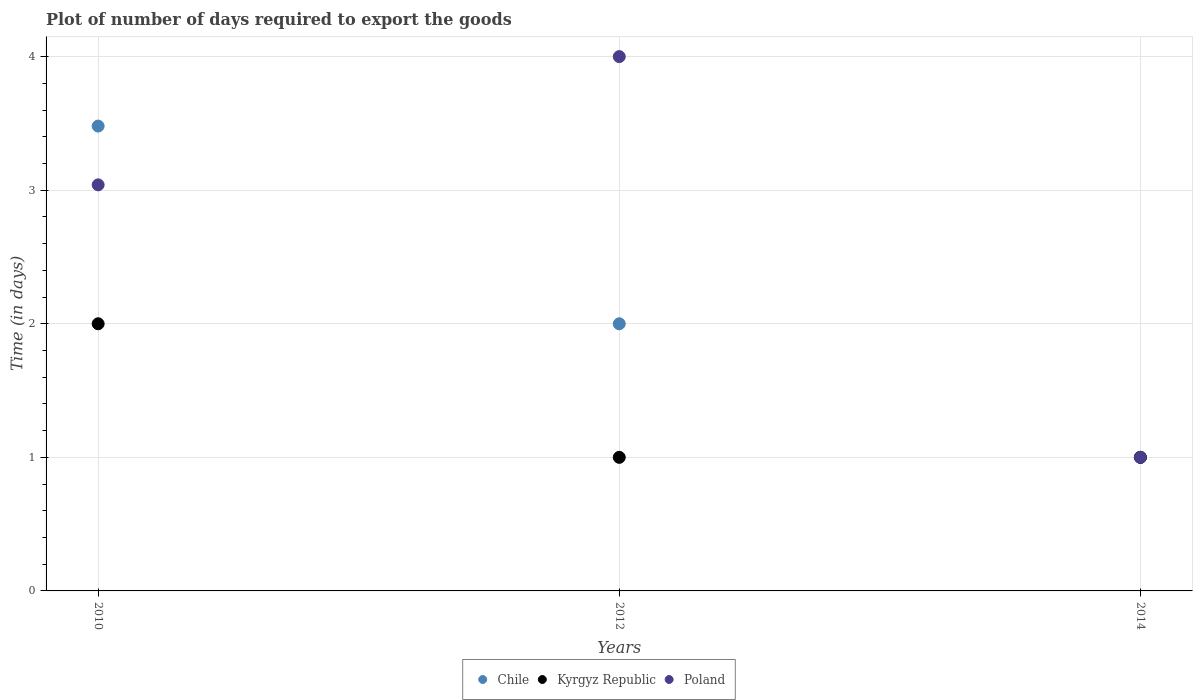How many different coloured dotlines are there?
Keep it short and to the point. 3. Across all years, what is the maximum time required to export goods in Chile?
Offer a very short reply. 3.48. In which year was the time required to export goods in Chile maximum?
Ensure brevity in your answer.  2010. What is the total time required to export goods in Poland in the graph?
Your response must be concise. 8.04. What is the difference between the time required to export goods in Chile in 2010 and that in 2012?
Offer a terse response. 1.48. What is the difference between the time required to export goods in Chile in 2014 and the time required to export goods in Kyrgyz Republic in 2012?
Your response must be concise. 0. What is the average time required to export goods in Chile per year?
Your answer should be compact. 2.16. In the year 2014, what is the difference between the time required to export goods in Poland and time required to export goods in Chile?
Make the answer very short. 0. In how many years, is the time required to export goods in Poland greater than 0.4 days?
Give a very brief answer. 3. What is the difference between the highest and the second highest time required to export goods in Kyrgyz Republic?
Your answer should be compact. 1. What is the difference between the highest and the lowest time required to export goods in Kyrgyz Republic?
Keep it short and to the point. 1. In how many years, is the time required to export goods in Poland greater than the average time required to export goods in Poland taken over all years?
Make the answer very short. 2. Is the time required to export goods in Kyrgyz Republic strictly greater than the time required to export goods in Chile over the years?
Make the answer very short. No. Is the time required to export goods in Poland strictly less than the time required to export goods in Chile over the years?
Your response must be concise. No. How many dotlines are there?
Your response must be concise. 3. Are the values on the major ticks of Y-axis written in scientific E-notation?
Make the answer very short. No. Does the graph contain grids?
Make the answer very short. Yes. Where does the legend appear in the graph?
Your response must be concise. Bottom center. How many legend labels are there?
Your answer should be very brief. 3. How are the legend labels stacked?
Make the answer very short. Horizontal. What is the title of the graph?
Your response must be concise. Plot of number of days required to export the goods. Does "Aruba" appear as one of the legend labels in the graph?
Offer a very short reply. No. What is the label or title of the X-axis?
Keep it short and to the point. Years. What is the label or title of the Y-axis?
Keep it short and to the point. Time (in days). What is the Time (in days) in Chile in 2010?
Give a very brief answer. 3.48. What is the Time (in days) of Kyrgyz Republic in 2010?
Offer a terse response. 2. What is the Time (in days) of Poland in 2010?
Your answer should be compact. 3.04. What is the Time (in days) in Kyrgyz Republic in 2012?
Your answer should be compact. 1. What is the Time (in days) in Chile in 2014?
Your answer should be compact. 1. What is the Time (in days) of Poland in 2014?
Ensure brevity in your answer.  1. Across all years, what is the maximum Time (in days) of Chile?
Provide a short and direct response. 3.48. Across all years, what is the maximum Time (in days) in Kyrgyz Republic?
Provide a succinct answer. 2. Across all years, what is the maximum Time (in days) of Poland?
Your answer should be very brief. 4. Across all years, what is the minimum Time (in days) of Kyrgyz Republic?
Offer a very short reply. 1. Across all years, what is the minimum Time (in days) in Poland?
Provide a succinct answer. 1. What is the total Time (in days) of Chile in the graph?
Your response must be concise. 6.48. What is the total Time (in days) of Kyrgyz Republic in the graph?
Offer a terse response. 4. What is the total Time (in days) in Poland in the graph?
Offer a very short reply. 8.04. What is the difference between the Time (in days) of Chile in 2010 and that in 2012?
Make the answer very short. 1.48. What is the difference between the Time (in days) of Kyrgyz Republic in 2010 and that in 2012?
Your answer should be very brief. 1. What is the difference between the Time (in days) of Poland in 2010 and that in 2012?
Give a very brief answer. -0.96. What is the difference between the Time (in days) in Chile in 2010 and that in 2014?
Offer a very short reply. 2.48. What is the difference between the Time (in days) in Poland in 2010 and that in 2014?
Provide a succinct answer. 2.04. What is the difference between the Time (in days) of Chile in 2012 and that in 2014?
Provide a short and direct response. 1. What is the difference between the Time (in days) in Kyrgyz Republic in 2012 and that in 2014?
Give a very brief answer. 0. What is the difference between the Time (in days) of Poland in 2012 and that in 2014?
Give a very brief answer. 3. What is the difference between the Time (in days) of Chile in 2010 and the Time (in days) of Kyrgyz Republic in 2012?
Make the answer very short. 2.48. What is the difference between the Time (in days) of Chile in 2010 and the Time (in days) of Poland in 2012?
Your answer should be very brief. -0.52. What is the difference between the Time (in days) in Chile in 2010 and the Time (in days) in Kyrgyz Republic in 2014?
Ensure brevity in your answer.  2.48. What is the difference between the Time (in days) of Chile in 2010 and the Time (in days) of Poland in 2014?
Keep it short and to the point. 2.48. What is the difference between the Time (in days) of Chile in 2012 and the Time (in days) of Poland in 2014?
Offer a very short reply. 1. What is the average Time (in days) in Chile per year?
Provide a succinct answer. 2.16. What is the average Time (in days) in Kyrgyz Republic per year?
Offer a very short reply. 1.33. What is the average Time (in days) in Poland per year?
Provide a succinct answer. 2.68. In the year 2010, what is the difference between the Time (in days) of Chile and Time (in days) of Kyrgyz Republic?
Offer a terse response. 1.48. In the year 2010, what is the difference between the Time (in days) in Chile and Time (in days) in Poland?
Offer a very short reply. 0.44. In the year 2010, what is the difference between the Time (in days) in Kyrgyz Republic and Time (in days) in Poland?
Give a very brief answer. -1.04. In the year 2012, what is the difference between the Time (in days) of Chile and Time (in days) of Kyrgyz Republic?
Offer a very short reply. 1. In the year 2014, what is the difference between the Time (in days) of Kyrgyz Republic and Time (in days) of Poland?
Ensure brevity in your answer.  0. What is the ratio of the Time (in days) in Chile in 2010 to that in 2012?
Offer a terse response. 1.74. What is the ratio of the Time (in days) in Kyrgyz Republic in 2010 to that in 2012?
Your answer should be compact. 2. What is the ratio of the Time (in days) of Poland in 2010 to that in 2012?
Make the answer very short. 0.76. What is the ratio of the Time (in days) in Chile in 2010 to that in 2014?
Keep it short and to the point. 3.48. What is the ratio of the Time (in days) of Poland in 2010 to that in 2014?
Keep it short and to the point. 3.04. What is the ratio of the Time (in days) of Kyrgyz Republic in 2012 to that in 2014?
Offer a very short reply. 1. What is the ratio of the Time (in days) in Poland in 2012 to that in 2014?
Your response must be concise. 4. What is the difference between the highest and the second highest Time (in days) of Chile?
Make the answer very short. 1.48. What is the difference between the highest and the second highest Time (in days) of Poland?
Ensure brevity in your answer.  0.96. What is the difference between the highest and the lowest Time (in days) of Chile?
Your answer should be very brief. 2.48. What is the difference between the highest and the lowest Time (in days) in Kyrgyz Republic?
Provide a short and direct response. 1. What is the difference between the highest and the lowest Time (in days) in Poland?
Your answer should be compact. 3. 